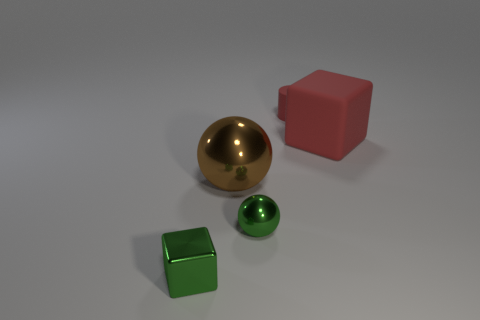What is the shape of the tiny thing that is the same color as the metallic block? sphere 